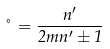<formula> <loc_0><loc_0><loc_500><loc_500>\nu = \frac { n ^ { \prime } } { 2 m n ^ { \prime } \pm 1 }</formula> 